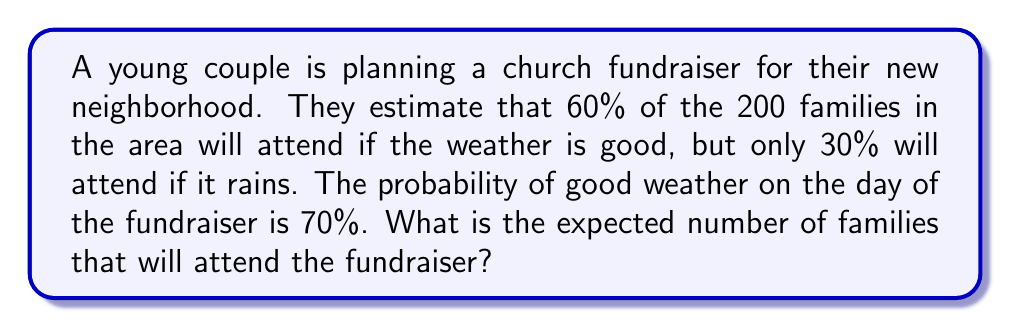Can you solve this math problem? Let's approach this problem step by step:

1) First, we need to calculate the probability of each scenario:
   
   P(Good weather) = 0.70
   P(Rain) = 1 - 0.70 = 0.30

2) Now, let's calculate the number of families attending in each scenario:
   
   If good weather: 200 * 0.60 = 120 families
   If rain: 200 * 0.30 = 60 families

3) The expected value is calculated by multiplying each outcome by its probability and then summing these products:

   $$ E = (120 * 0.70) + (60 * 0.30) $$

4) Let's calculate:
   
   $$ E = 84 + 18 = 102 $$

Therefore, the expected number of families attending the fundraiser is 102.
Answer: 102 families 